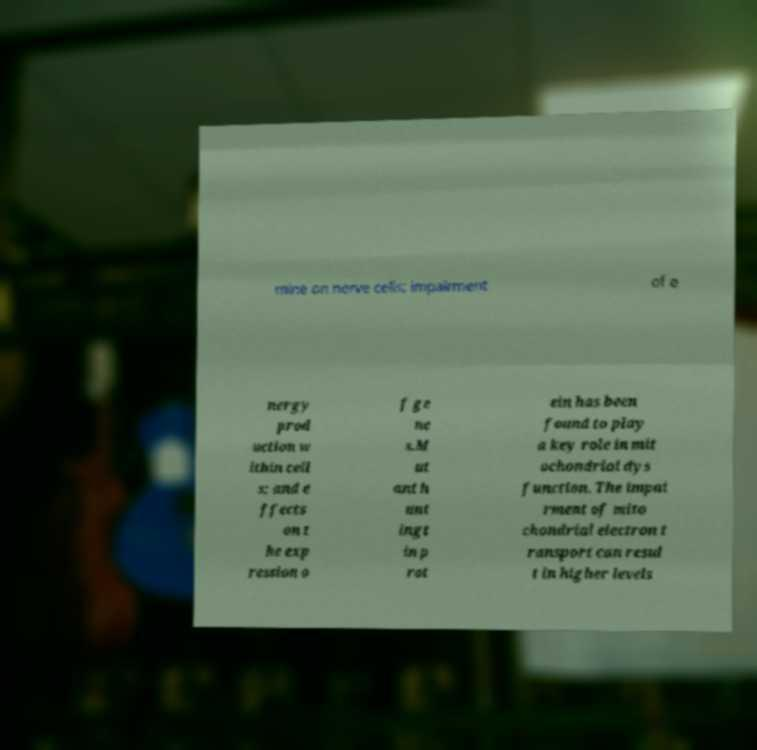I need the written content from this picture converted into text. Can you do that? mine on nerve cells; impairment of e nergy prod uction w ithin cell s; and e ffects on t he exp ression o f ge ne s.M ut ant h unt ingt in p rot ein has been found to play a key role in mit ochondrial dys function. The impai rment of mito chondrial electron t ransport can resul t in higher levels 